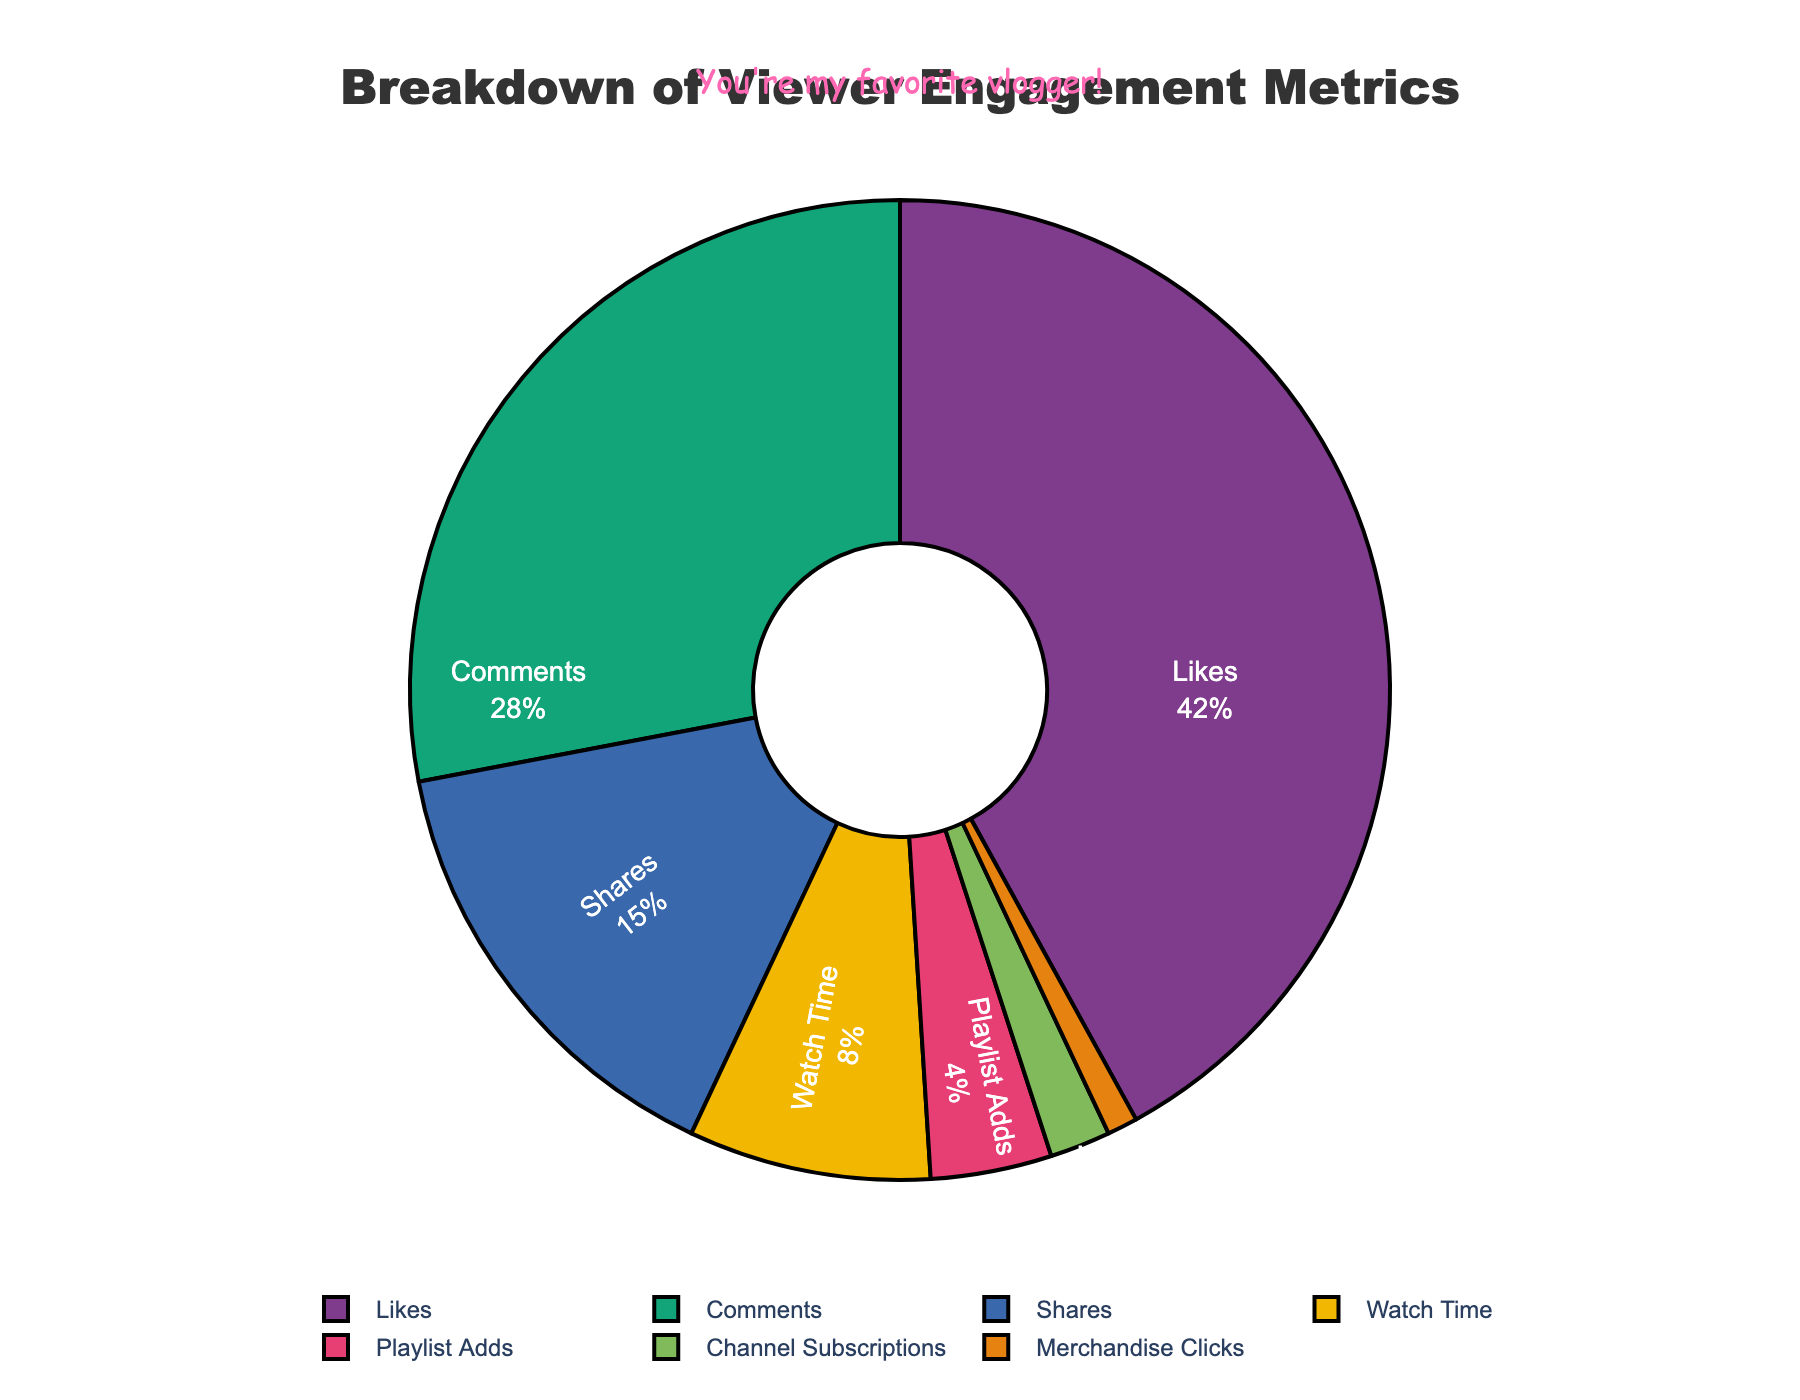What percentage of viewer engagement metrics is attributed to comments? The pie chart shows the percentage of each metric. From the chart, comments constitute 28% of the total viewer engagement metrics.
Answer: 28% Which metric has the lowest percentage of viewer engagement metrics? The pie chart indicates that Merchandise Clicks have the lowest percentage at 1%.
Answer: Merchandise Clicks How much greater is the percentage of likes compared to shares? The percentage for likes is 42% and for shares is 15%. The difference is 42% - 15% = 27%.
Answer: 27% What is the combined percentage of watch time, playlist adds, and channel subscriptions? From the pie chart, watch time is 8%, playlist adds are 4%, and channel subscriptions are 2%. Adding them together: 8% + 4% + 2% = 14%.
Answer: 14% Are comments or shares a higher viewer engagement metric, and by what percentage? The percentage for comments is 28% and for shares is 15%. Comments are higher by 28% - 15% = 13%.
Answer: Comments by 13% Which engagement metric has the highest percentage and how is it visually represented on the pie chart? Likes have the highest percentage at 42%. It is visually represented as the largest slice of the pie chart.
Answer: Likes, largest slice How does the total percentage of likes and comments compare to the total of all other metrics? Likes are 42% and comments are 28%. Combined, they are 42% + 28% = 70%. All other metrics combined are 100% - 70% = 30%.
Answer: Likes and comments: 70%, Others: 30% Identify the three smallest viewer engagement metrics and state their percentages. The three smallest slices on the pie chart are Channel Subscriptions (2%), Playlist Adds (4%), and Merchandise Clicks (1%).
Answer: Channel Subscriptions: 2%, Playlist Adds: 4%, Merchandise Clicks: 1% What percentage of viewer engagement is attributed to watch time and playlist adds together? Watch time accounts for 8% and playlist adds for 4%. Together, they total 8% + 4% = 12%.
Answer: 12% 